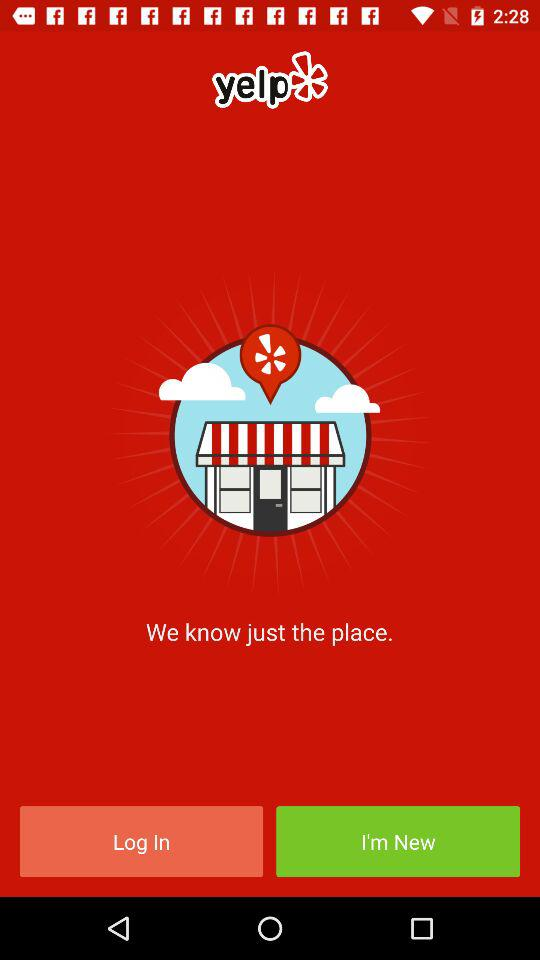What is the app name? The app name is "yelp". 